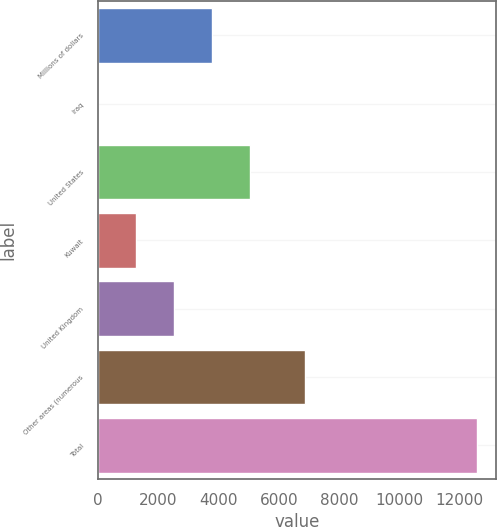Convert chart to OTSL. <chart><loc_0><loc_0><loc_500><loc_500><bar_chart><fcel>Millions of dollars<fcel>Iraq<fcel>United States<fcel>Kuwait<fcel>United Kingdom<fcel>Other areas (numerous<fcel>Total<nl><fcel>3772.3<fcel>1<fcel>5029.4<fcel>1258.1<fcel>2515.2<fcel>6861<fcel>12572<nl></chart> 